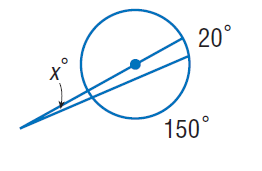Question: Find x. Assume that any segment that appears to be tangent is tangent.
Choices:
A. 5
B. 10
C. 20
D. 150
Answer with the letter. Answer: A 